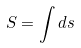<formula> <loc_0><loc_0><loc_500><loc_500>S = \int d s</formula> 